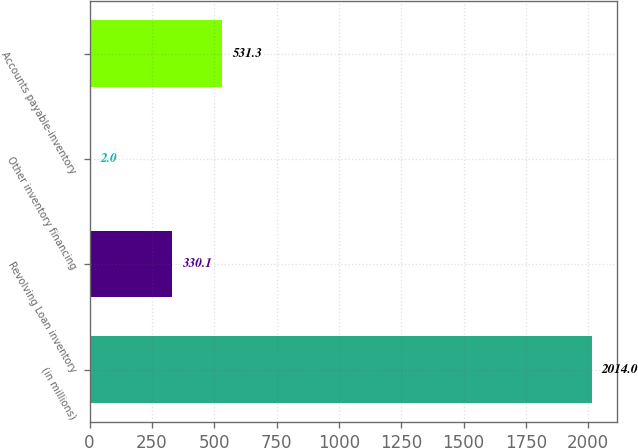Convert chart. <chart><loc_0><loc_0><loc_500><loc_500><bar_chart><fcel>(in millions)<fcel>Revolving Loan inventory<fcel>Other inventory financing<fcel>Accounts payable-inventory<nl><fcel>2014<fcel>330.1<fcel>2<fcel>531.3<nl></chart> 